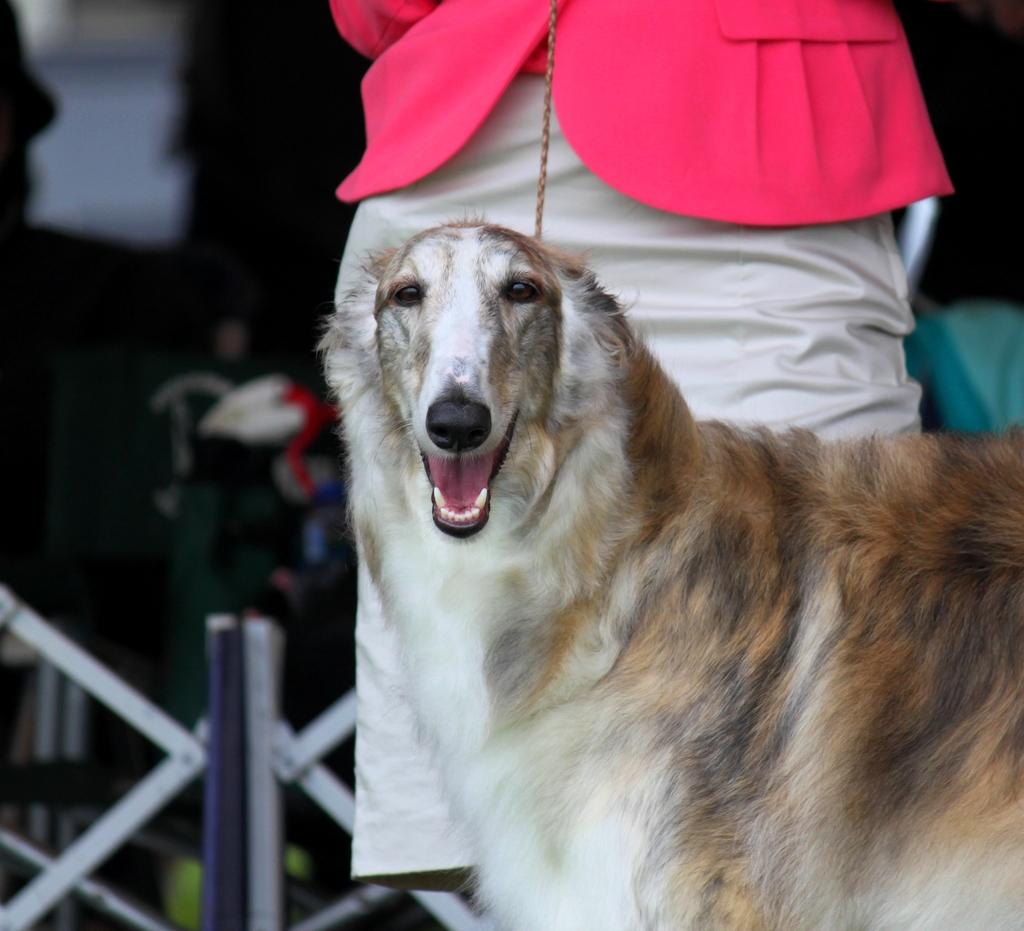What is the main subject in the middle of the picture? There is a dog in the middle of the picture. Can you describe the person in relation to the dog? There is a person behind the dog. How would you describe the background of the image? The background of the image is blurred. What type of beef can be seen hanging from the icicle in the image? There is no beef or icicle present in the image. 